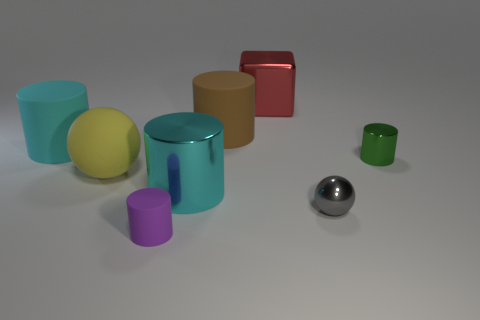Subtract all green cylinders. How many cylinders are left? 4 Subtract all cyan metal cylinders. How many cylinders are left? 4 Subtract all brown cylinders. Subtract all blue blocks. How many cylinders are left? 4 Add 2 purple matte things. How many objects exist? 10 Subtract all cubes. How many objects are left? 7 Subtract 0 gray cylinders. How many objects are left? 8 Subtract all tiny spheres. Subtract all green metallic cylinders. How many objects are left? 6 Add 4 small gray spheres. How many small gray spheres are left? 5 Add 5 big brown rubber objects. How many big brown rubber objects exist? 6 